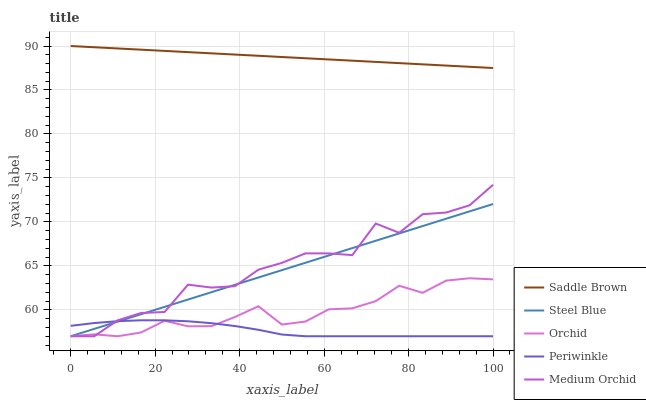Does Periwinkle have the minimum area under the curve?
Answer yes or no. Yes. Does Saddle Brown have the maximum area under the curve?
Answer yes or no. Yes. Does Orchid have the minimum area under the curve?
Answer yes or no. No. Does Orchid have the maximum area under the curve?
Answer yes or no. No. Is Steel Blue the smoothest?
Answer yes or no. Yes. Is Medium Orchid the roughest?
Answer yes or no. Yes. Is Orchid the smoothest?
Answer yes or no. No. Is Orchid the roughest?
Answer yes or no. No. Does Medium Orchid have the lowest value?
Answer yes or no. Yes. Does Saddle Brown have the lowest value?
Answer yes or no. No. Does Saddle Brown have the highest value?
Answer yes or no. Yes. Does Orchid have the highest value?
Answer yes or no. No. Is Orchid less than Saddle Brown?
Answer yes or no. Yes. Is Saddle Brown greater than Orchid?
Answer yes or no. Yes. Does Orchid intersect Medium Orchid?
Answer yes or no. Yes. Is Orchid less than Medium Orchid?
Answer yes or no. No. Is Orchid greater than Medium Orchid?
Answer yes or no. No. Does Orchid intersect Saddle Brown?
Answer yes or no. No. 